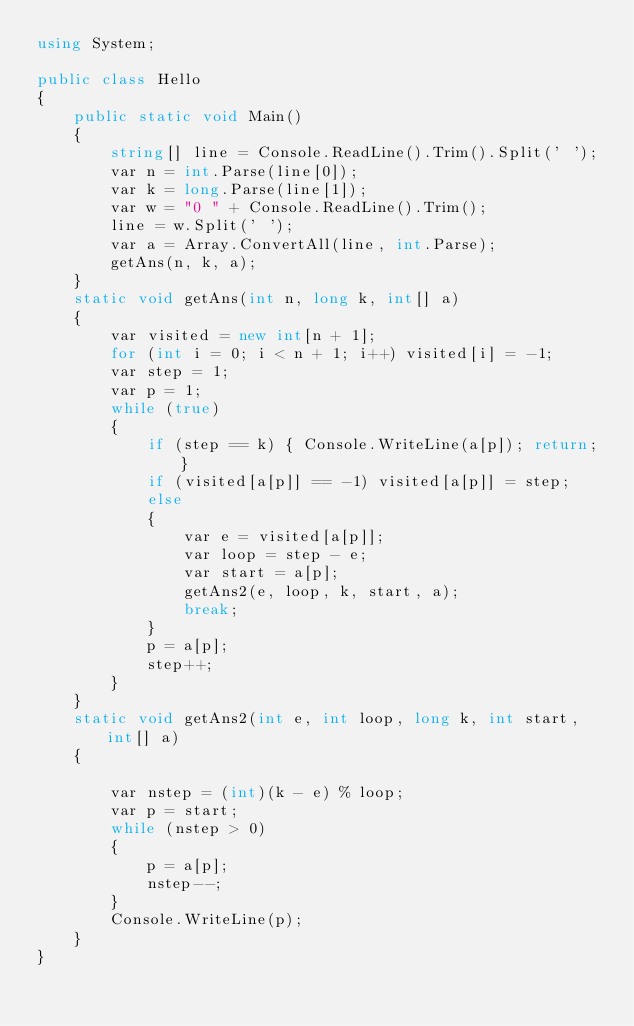Convert code to text. <code><loc_0><loc_0><loc_500><loc_500><_C#_>using System;

public class Hello
{
    public static void Main()
    {
        string[] line = Console.ReadLine().Trim().Split(' ');
        var n = int.Parse(line[0]);
        var k = long.Parse(line[1]);
        var w = "0 " + Console.ReadLine().Trim();
        line = w.Split(' ');
        var a = Array.ConvertAll(line, int.Parse);
        getAns(n, k, a);
    }
    static void getAns(int n, long k, int[] a)
    {
        var visited = new int[n + 1];
        for (int i = 0; i < n + 1; i++) visited[i] = -1;
        var step = 1;
        var p = 1;
        while (true)
        {
            if (step == k) { Console.WriteLine(a[p]); return; }
            if (visited[a[p]] == -1) visited[a[p]] = step;
            else
            {
                var e = visited[a[p]];
                var loop = step - e;
                var start = a[p];
                getAns2(e, loop, k, start, a);
                break;
            }
            p = a[p];
            step++;
        }
    }
    static void getAns2(int e, int loop, long k, int start, int[] a)
    {

        var nstep = (int)(k - e) % loop;
        var p = start;
        while (nstep > 0)
        {
            p = a[p];
            nstep--;
        }
        Console.WriteLine(p);
    }
}

</code> 